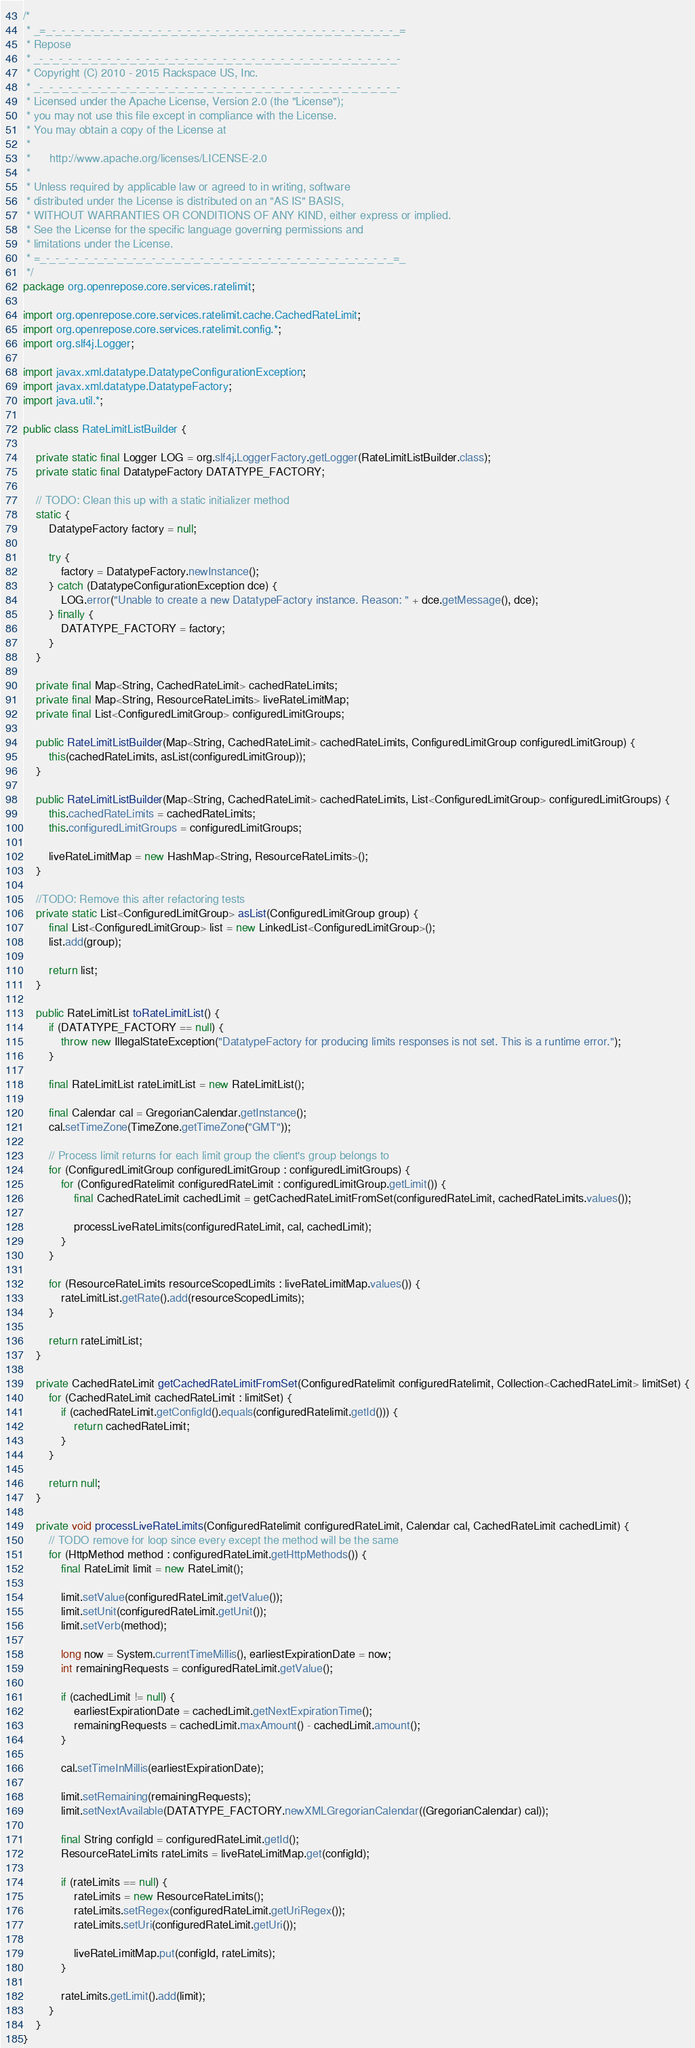<code> <loc_0><loc_0><loc_500><loc_500><_Java_>/*
 * _=_-_-_-_-_-_-_-_-_-_-_-_-_-_-_-_-_-_-_-_-_-_-_-_-_-_-_-_-_-_-_-_-_-_-_-_-_=
 * Repose
 * _-_-_-_-_-_-_-_-_-_-_-_-_-_-_-_-_-_-_-_-_-_-_-_-_-_-_-_-_-_-_-_-_-_-_-_-_-_-
 * Copyright (C) 2010 - 2015 Rackspace US, Inc.
 * _-_-_-_-_-_-_-_-_-_-_-_-_-_-_-_-_-_-_-_-_-_-_-_-_-_-_-_-_-_-_-_-_-_-_-_-_-_-
 * Licensed under the Apache License, Version 2.0 (the "License");
 * you may not use this file except in compliance with the License.
 * You may obtain a copy of the License at
 * 
 *      http://www.apache.org/licenses/LICENSE-2.0
 * 
 * Unless required by applicable law or agreed to in writing, software
 * distributed under the License is distributed on an "AS IS" BASIS,
 * WITHOUT WARRANTIES OR CONDITIONS OF ANY KIND, either express or implied.
 * See the License for the specific language governing permissions and
 * limitations under the License.
 * =_-_-_-_-_-_-_-_-_-_-_-_-_-_-_-_-_-_-_-_-_-_-_-_-_-_-_-_-_-_-_-_-_-_-_-_-_=_
 */
package org.openrepose.core.services.ratelimit;

import org.openrepose.core.services.ratelimit.cache.CachedRateLimit;
import org.openrepose.core.services.ratelimit.config.*;
import org.slf4j.Logger;

import javax.xml.datatype.DatatypeConfigurationException;
import javax.xml.datatype.DatatypeFactory;
import java.util.*;

public class RateLimitListBuilder {

    private static final Logger LOG = org.slf4j.LoggerFactory.getLogger(RateLimitListBuilder.class);
    private static final DatatypeFactory DATATYPE_FACTORY;

    // TODO: Clean this up with a static initializer method
    static {
        DatatypeFactory factory = null;

        try {
            factory = DatatypeFactory.newInstance();
        } catch (DatatypeConfigurationException dce) {
            LOG.error("Unable to create a new DatatypeFactory instance. Reason: " + dce.getMessage(), dce);
        } finally {
            DATATYPE_FACTORY = factory;
        }
    }

    private final Map<String, CachedRateLimit> cachedRateLimits;
    private final Map<String, ResourceRateLimits> liveRateLimitMap;
    private final List<ConfiguredLimitGroup> configuredLimitGroups;

    public RateLimitListBuilder(Map<String, CachedRateLimit> cachedRateLimits, ConfiguredLimitGroup configuredLimitGroup) {
        this(cachedRateLimits, asList(configuredLimitGroup));
    }

    public RateLimitListBuilder(Map<String, CachedRateLimit> cachedRateLimits, List<ConfiguredLimitGroup> configuredLimitGroups) {
        this.cachedRateLimits = cachedRateLimits;
        this.configuredLimitGroups = configuredLimitGroups;

        liveRateLimitMap = new HashMap<String, ResourceRateLimits>();
    }

    //TODO: Remove this after refactoring tests
    private static List<ConfiguredLimitGroup> asList(ConfiguredLimitGroup group) {
        final List<ConfiguredLimitGroup> list = new LinkedList<ConfiguredLimitGroup>();
        list.add(group);

        return list;
    }

    public RateLimitList toRateLimitList() {
        if (DATATYPE_FACTORY == null) {
            throw new IllegalStateException("DatatypeFactory for producing limits responses is not set. This is a runtime error.");
        }

        final RateLimitList rateLimitList = new RateLimitList();

        final Calendar cal = GregorianCalendar.getInstance();
        cal.setTimeZone(TimeZone.getTimeZone("GMT"));

        // Process limit returns for each limit group the client's group belongs to
        for (ConfiguredLimitGroup configuredLimitGroup : configuredLimitGroups) {
            for (ConfiguredRatelimit configuredRateLimit : configuredLimitGroup.getLimit()) {
                final CachedRateLimit cachedLimit = getCachedRateLimitFromSet(configuredRateLimit, cachedRateLimits.values());

                processLiveRateLimits(configuredRateLimit, cal, cachedLimit);
            }
        }

        for (ResourceRateLimits resourceScopedLimits : liveRateLimitMap.values()) {
            rateLimitList.getRate().add(resourceScopedLimits);
        }

        return rateLimitList;
    }

    private CachedRateLimit getCachedRateLimitFromSet(ConfiguredRatelimit configuredRatelimit, Collection<CachedRateLimit> limitSet) {
        for (CachedRateLimit cachedRateLimit : limitSet) {
            if (cachedRateLimit.getConfigId().equals(configuredRatelimit.getId())) {
                return cachedRateLimit;
            }
        }

        return null;
    }

    private void processLiveRateLimits(ConfiguredRatelimit configuredRateLimit, Calendar cal, CachedRateLimit cachedLimit) {
        // TODO remove for loop since every except the method will be the same
        for (HttpMethod method : configuredRateLimit.getHttpMethods()) {
            final RateLimit limit = new RateLimit();

            limit.setValue(configuredRateLimit.getValue());
            limit.setUnit(configuredRateLimit.getUnit());
            limit.setVerb(method);

            long now = System.currentTimeMillis(), earliestExpirationDate = now;
            int remainingRequests = configuredRateLimit.getValue();

            if (cachedLimit != null) {
                earliestExpirationDate = cachedLimit.getNextExpirationTime();
                remainingRequests = cachedLimit.maxAmount() - cachedLimit.amount();
            }

            cal.setTimeInMillis(earliestExpirationDate);

            limit.setRemaining(remainingRequests);
            limit.setNextAvailable(DATATYPE_FACTORY.newXMLGregorianCalendar((GregorianCalendar) cal));

            final String configId = configuredRateLimit.getId();
            ResourceRateLimits rateLimits = liveRateLimitMap.get(configId);

            if (rateLimits == null) {
                rateLimits = new ResourceRateLimits();
                rateLimits.setRegex(configuredRateLimit.getUriRegex());
                rateLimits.setUri(configuredRateLimit.getUri());

                liveRateLimitMap.put(configId, rateLimits);
            }

            rateLimits.getLimit().add(limit);
        }
    }
}
</code> 